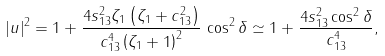<formula> <loc_0><loc_0><loc_500><loc_500>| u | ^ { 2 } = 1 + \frac { 4 s _ { 1 3 } ^ { 2 } \zeta _ { 1 } \left ( \zeta _ { 1 } + c _ { 1 3 } ^ { 2 } \right ) } { c _ { 1 3 } ^ { 4 } \left ( \zeta _ { 1 } + 1 \right ) ^ { 2 } } \, \cos ^ { 2 } { \delta } \simeq 1 + \frac { 4 s _ { 1 3 } ^ { 2 } \cos ^ { 2 } { \delta } } { c _ { 1 3 } ^ { 4 } } ,</formula> 